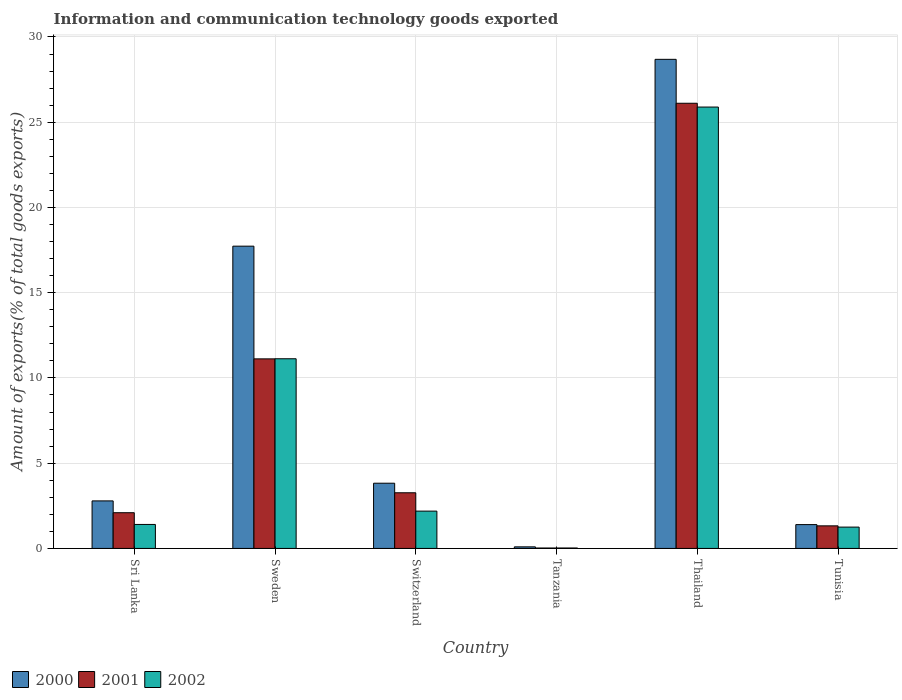Are the number of bars per tick equal to the number of legend labels?
Provide a succinct answer. Yes. How many bars are there on the 3rd tick from the left?
Make the answer very short. 3. What is the label of the 2nd group of bars from the left?
Your answer should be very brief. Sweden. In how many cases, is the number of bars for a given country not equal to the number of legend labels?
Provide a short and direct response. 0. What is the amount of goods exported in 2002 in Tunisia?
Make the answer very short. 1.25. Across all countries, what is the maximum amount of goods exported in 2001?
Offer a very short reply. 26.11. Across all countries, what is the minimum amount of goods exported in 2001?
Give a very brief answer. 0.03. In which country was the amount of goods exported in 2002 maximum?
Provide a short and direct response. Thailand. In which country was the amount of goods exported in 2000 minimum?
Provide a short and direct response. Tanzania. What is the total amount of goods exported in 2001 in the graph?
Provide a short and direct response. 43.94. What is the difference between the amount of goods exported in 2002 in Switzerland and that in Tunisia?
Ensure brevity in your answer.  0.94. What is the difference between the amount of goods exported in 2002 in Sri Lanka and the amount of goods exported in 2001 in Tunisia?
Ensure brevity in your answer.  0.08. What is the average amount of goods exported in 2000 per country?
Make the answer very short. 9.09. What is the difference between the amount of goods exported of/in 2000 and amount of goods exported of/in 2002 in Thailand?
Your answer should be very brief. 2.8. What is the ratio of the amount of goods exported in 2002 in Sweden to that in Tanzania?
Give a very brief answer. 436.69. Is the amount of goods exported in 2001 in Switzerland less than that in Thailand?
Your answer should be very brief. Yes. What is the difference between the highest and the second highest amount of goods exported in 2001?
Provide a succinct answer. -22.85. What is the difference between the highest and the lowest amount of goods exported in 2000?
Keep it short and to the point. 28.6. Is the sum of the amount of goods exported in 2000 in Sri Lanka and Tunisia greater than the maximum amount of goods exported in 2001 across all countries?
Ensure brevity in your answer.  No. What does the 2nd bar from the right in Sri Lanka represents?
Your answer should be compact. 2001. Is it the case that in every country, the sum of the amount of goods exported in 2002 and amount of goods exported in 2000 is greater than the amount of goods exported in 2001?
Your answer should be compact. Yes. Are all the bars in the graph horizontal?
Your answer should be very brief. No. How many countries are there in the graph?
Your answer should be very brief. 6. What is the difference between two consecutive major ticks on the Y-axis?
Give a very brief answer. 5. Are the values on the major ticks of Y-axis written in scientific E-notation?
Your answer should be very brief. No. How many legend labels are there?
Give a very brief answer. 3. What is the title of the graph?
Offer a very short reply. Information and communication technology goods exported. What is the label or title of the Y-axis?
Offer a very short reply. Amount of exports(% of total goods exports). What is the Amount of exports(% of total goods exports) in 2000 in Sri Lanka?
Your response must be concise. 2.79. What is the Amount of exports(% of total goods exports) of 2001 in Sri Lanka?
Make the answer very short. 2.1. What is the Amount of exports(% of total goods exports) in 2002 in Sri Lanka?
Offer a terse response. 1.41. What is the Amount of exports(% of total goods exports) of 2000 in Sweden?
Give a very brief answer. 17.73. What is the Amount of exports(% of total goods exports) of 2001 in Sweden?
Provide a short and direct response. 11.12. What is the Amount of exports(% of total goods exports) in 2002 in Sweden?
Provide a succinct answer. 11.13. What is the Amount of exports(% of total goods exports) in 2000 in Switzerland?
Give a very brief answer. 3.83. What is the Amount of exports(% of total goods exports) of 2001 in Switzerland?
Provide a short and direct response. 3.26. What is the Amount of exports(% of total goods exports) of 2002 in Switzerland?
Ensure brevity in your answer.  2.19. What is the Amount of exports(% of total goods exports) of 2000 in Tanzania?
Keep it short and to the point. 0.09. What is the Amount of exports(% of total goods exports) in 2001 in Tanzania?
Your answer should be very brief. 0.03. What is the Amount of exports(% of total goods exports) in 2002 in Tanzania?
Ensure brevity in your answer.  0.03. What is the Amount of exports(% of total goods exports) of 2000 in Thailand?
Give a very brief answer. 28.69. What is the Amount of exports(% of total goods exports) of 2001 in Thailand?
Provide a short and direct response. 26.11. What is the Amount of exports(% of total goods exports) in 2002 in Thailand?
Make the answer very short. 25.89. What is the Amount of exports(% of total goods exports) in 2000 in Tunisia?
Ensure brevity in your answer.  1.4. What is the Amount of exports(% of total goods exports) in 2001 in Tunisia?
Offer a terse response. 1.32. What is the Amount of exports(% of total goods exports) in 2002 in Tunisia?
Make the answer very short. 1.25. Across all countries, what is the maximum Amount of exports(% of total goods exports) of 2000?
Your response must be concise. 28.69. Across all countries, what is the maximum Amount of exports(% of total goods exports) of 2001?
Make the answer very short. 26.11. Across all countries, what is the maximum Amount of exports(% of total goods exports) of 2002?
Provide a succinct answer. 25.89. Across all countries, what is the minimum Amount of exports(% of total goods exports) in 2000?
Your answer should be compact. 0.09. Across all countries, what is the minimum Amount of exports(% of total goods exports) of 2001?
Your answer should be compact. 0.03. Across all countries, what is the minimum Amount of exports(% of total goods exports) in 2002?
Offer a very short reply. 0.03. What is the total Amount of exports(% of total goods exports) in 2000 in the graph?
Offer a very short reply. 54.52. What is the total Amount of exports(% of total goods exports) of 2001 in the graph?
Ensure brevity in your answer.  43.94. What is the total Amount of exports(% of total goods exports) in 2002 in the graph?
Offer a very short reply. 41.89. What is the difference between the Amount of exports(% of total goods exports) of 2000 in Sri Lanka and that in Sweden?
Keep it short and to the point. -14.94. What is the difference between the Amount of exports(% of total goods exports) of 2001 in Sri Lanka and that in Sweden?
Keep it short and to the point. -9.02. What is the difference between the Amount of exports(% of total goods exports) of 2002 in Sri Lanka and that in Sweden?
Provide a succinct answer. -9.72. What is the difference between the Amount of exports(% of total goods exports) in 2000 in Sri Lanka and that in Switzerland?
Make the answer very short. -1.04. What is the difference between the Amount of exports(% of total goods exports) of 2001 in Sri Lanka and that in Switzerland?
Ensure brevity in your answer.  -1.17. What is the difference between the Amount of exports(% of total goods exports) of 2002 in Sri Lanka and that in Switzerland?
Ensure brevity in your answer.  -0.78. What is the difference between the Amount of exports(% of total goods exports) in 2000 in Sri Lanka and that in Tanzania?
Offer a very short reply. 2.7. What is the difference between the Amount of exports(% of total goods exports) in 2001 in Sri Lanka and that in Tanzania?
Offer a very short reply. 2.07. What is the difference between the Amount of exports(% of total goods exports) of 2002 in Sri Lanka and that in Tanzania?
Keep it short and to the point. 1.38. What is the difference between the Amount of exports(% of total goods exports) in 2000 in Sri Lanka and that in Thailand?
Keep it short and to the point. -25.9. What is the difference between the Amount of exports(% of total goods exports) in 2001 in Sri Lanka and that in Thailand?
Provide a short and direct response. -24.02. What is the difference between the Amount of exports(% of total goods exports) of 2002 in Sri Lanka and that in Thailand?
Provide a succinct answer. -24.48. What is the difference between the Amount of exports(% of total goods exports) of 2000 in Sri Lanka and that in Tunisia?
Make the answer very short. 1.39. What is the difference between the Amount of exports(% of total goods exports) in 2001 in Sri Lanka and that in Tunisia?
Your answer should be compact. 0.77. What is the difference between the Amount of exports(% of total goods exports) in 2002 in Sri Lanka and that in Tunisia?
Your answer should be very brief. 0.16. What is the difference between the Amount of exports(% of total goods exports) in 2000 in Sweden and that in Switzerland?
Provide a succinct answer. 13.9. What is the difference between the Amount of exports(% of total goods exports) in 2001 in Sweden and that in Switzerland?
Your answer should be compact. 7.85. What is the difference between the Amount of exports(% of total goods exports) in 2002 in Sweden and that in Switzerland?
Ensure brevity in your answer.  8.94. What is the difference between the Amount of exports(% of total goods exports) of 2000 in Sweden and that in Tanzania?
Your response must be concise. 17.64. What is the difference between the Amount of exports(% of total goods exports) in 2001 in Sweden and that in Tanzania?
Provide a short and direct response. 11.09. What is the difference between the Amount of exports(% of total goods exports) of 2002 in Sweden and that in Tanzania?
Give a very brief answer. 11.1. What is the difference between the Amount of exports(% of total goods exports) of 2000 in Sweden and that in Thailand?
Ensure brevity in your answer.  -10.96. What is the difference between the Amount of exports(% of total goods exports) of 2001 in Sweden and that in Thailand?
Provide a short and direct response. -14.99. What is the difference between the Amount of exports(% of total goods exports) in 2002 in Sweden and that in Thailand?
Your response must be concise. -14.76. What is the difference between the Amount of exports(% of total goods exports) in 2000 in Sweden and that in Tunisia?
Offer a very short reply. 16.33. What is the difference between the Amount of exports(% of total goods exports) of 2001 in Sweden and that in Tunisia?
Your answer should be very brief. 9.79. What is the difference between the Amount of exports(% of total goods exports) in 2002 in Sweden and that in Tunisia?
Give a very brief answer. 9.87. What is the difference between the Amount of exports(% of total goods exports) in 2000 in Switzerland and that in Tanzania?
Give a very brief answer. 3.73. What is the difference between the Amount of exports(% of total goods exports) in 2001 in Switzerland and that in Tanzania?
Give a very brief answer. 3.24. What is the difference between the Amount of exports(% of total goods exports) of 2002 in Switzerland and that in Tanzania?
Make the answer very short. 2.16. What is the difference between the Amount of exports(% of total goods exports) in 2000 in Switzerland and that in Thailand?
Your response must be concise. -24.86. What is the difference between the Amount of exports(% of total goods exports) of 2001 in Switzerland and that in Thailand?
Keep it short and to the point. -22.85. What is the difference between the Amount of exports(% of total goods exports) of 2002 in Switzerland and that in Thailand?
Offer a terse response. -23.7. What is the difference between the Amount of exports(% of total goods exports) of 2000 in Switzerland and that in Tunisia?
Give a very brief answer. 2.43. What is the difference between the Amount of exports(% of total goods exports) of 2001 in Switzerland and that in Tunisia?
Ensure brevity in your answer.  1.94. What is the difference between the Amount of exports(% of total goods exports) of 2002 in Switzerland and that in Tunisia?
Give a very brief answer. 0.94. What is the difference between the Amount of exports(% of total goods exports) in 2000 in Tanzania and that in Thailand?
Offer a terse response. -28.6. What is the difference between the Amount of exports(% of total goods exports) of 2001 in Tanzania and that in Thailand?
Make the answer very short. -26.09. What is the difference between the Amount of exports(% of total goods exports) in 2002 in Tanzania and that in Thailand?
Your answer should be compact. -25.86. What is the difference between the Amount of exports(% of total goods exports) in 2000 in Tanzania and that in Tunisia?
Provide a short and direct response. -1.3. What is the difference between the Amount of exports(% of total goods exports) of 2001 in Tanzania and that in Tunisia?
Your answer should be compact. -1.3. What is the difference between the Amount of exports(% of total goods exports) of 2002 in Tanzania and that in Tunisia?
Your answer should be very brief. -1.23. What is the difference between the Amount of exports(% of total goods exports) in 2000 in Thailand and that in Tunisia?
Make the answer very short. 27.29. What is the difference between the Amount of exports(% of total goods exports) in 2001 in Thailand and that in Tunisia?
Your answer should be compact. 24.79. What is the difference between the Amount of exports(% of total goods exports) in 2002 in Thailand and that in Tunisia?
Offer a terse response. 24.64. What is the difference between the Amount of exports(% of total goods exports) of 2000 in Sri Lanka and the Amount of exports(% of total goods exports) of 2001 in Sweden?
Offer a terse response. -8.33. What is the difference between the Amount of exports(% of total goods exports) of 2000 in Sri Lanka and the Amount of exports(% of total goods exports) of 2002 in Sweden?
Your response must be concise. -8.34. What is the difference between the Amount of exports(% of total goods exports) in 2001 in Sri Lanka and the Amount of exports(% of total goods exports) in 2002 in Sweden?
Make the answer very short. -9.03. What is the difference between the Amount of exports(% of total goods exports) of 2000 in Sri Lanka and the Amount of exports(% of total goods exports) of 2001 in Switzerland?
Make the answer very short. -0.48. What is the difference between the Amount of exports(% of total goods exports) of 2000 in Sri Lanka and the Amount of exports(% of total goods exports) of 2002 in Switzerland?
Provide a succinct answer. 0.6. What is the difference between the Amount of exports(% of total goods exports) of 2001 in Sri Lanka and the Amount of exports(% of total goods exports) of 2002 in Switzerland?
Offer a terse response. -0.09. What is the difference between the Amount of exports(% of total goods exports) of 2000 in Sri Lanka and the Amount of exports(% of total goods exports) of 2001 in Tanzania?
Your answer should be compact. 2.76. What is the difference between the Amount of exports(% of total goods exports) in 2000 in Sri Lanka and the Amount of exports(% of total goods exports) in 2002 in Tanzania?
Your response must be concise. 2.76. What is the difference between the Amount of exports(% of total goods exports) in 2001 in Sri Lanka and the Amount of exports(% of total goods exports) in 2002 in Tanzania?
Your answer should be very brief. 2.07. What is the difference between the Amount of exports(% of total goods exports) in 2000 in Sri Lanka and the Amount of exports(% of total goods exports) in 2001 in Thailand?
Make the answer very short. -23.32. What is the difference between the Amount of exports(% of total goods exports) of 2000 in Sri Lanka and the Amount of exports(% of total goods exports) of 2002 in Thailand?
Ensure brevity in your answer.  -23.1. What is the difference between the Amount of exports(% of total goods exports) in 2001 in Sri Lanka and the Amount of exports(% of total goods exports) in 2002 in Thailand?
Make the answer very short. -23.79. What is the difference between the Amount of exports(% of total goods exports) of 2000 in Sri Lanka and the Amount of exports(% of total goods exports) of 2001 in Tunisia?
Ensure brevity in your answer.  1.46. What is the difference between the Amount of exports(% of total goods exports) in 2000 in Sri Lanka and the Amount of exports(% of total goods exports) in 2002 in Tunisia?
Keep it short and to the point. 1.54. What is the difference between the Amount of exports(% of total goods exports) in 2001 in Sri Lanka and the Amount of exports(% of total goods exports) in 2002 in Tunisia?
Your response must be concise. 0.84. What is the difference between the Amount of exports(% of total goods exports) of 2000 in Sweden and the Amount of exports(% of total goods exports) of 2001 in Switzerland?
Offer a terse response. 14.47. What is the difference between the Amount of exports(% of total goods exports) of 2000 in Sweden and the Amount of exports(% of total goods exports) of 2002 in Switzerland?
Keep it short and to the point. 15.54. What is the difference between the Amount of exports(% of total goods exports) in 2001 in Sweden and the Amount of exports(% of total goods exports) in 2002 in Switzerland?
Provide a succinct answer. 8.93. What is the difference between the Amount of exports(% of total goods exports) of 2000 in Sweden and the Amount of exports(% of total goods exports) of 2001 in Tanzania?
Ensure brevity in your answer.  17.7. What is the difference between the Amount of exports(% of total goods exports) in 2000 in Sweden and the Amount of exports(% of total goods exports) in 2002 in Tanzania?
Provide a short and direct response. 17.7. What is the difference between the Amount of exports(% of total goods exports) in 2001 in Sweden and the Amount of exports(% of total goods exports) in 2002 in Tanzania?
Your answer should be very brief. 11.09. What is the difference between the Amount of exports(% of total goods exports) in 2000 in Sweden and the Amount of exports(% of total goods exports) in 2001 in Thailand?
Make the answer very short. -8.38. What is the difference between the Amount of exports(% of total goods exports) in 2000 in Sweden and the Amount of exports(% of total goods exports) in 2002 in Thailand?
Your response must be concise. -8.16. What is the difference between the Amount of exports(% of total goods exports) of 2001 in Sweden and the Amount of exports(% of total goods exports) of 2002 in Thailand?
Your answer should be compact. -14.77. What is the difference between the Amount of exports(% of total goods exports) in 2000 in Sweden and the Amount of exports(% of total goods exports) in 2001 in Tunisia?
Ensure brevity in your answer.  16.41. What is the difference between the Amount of exports(% of total goods exports) of 2000 in Sweden and the Amount of exports(% of total goods exports) of 2002 in Tunisia?
Offer a very short reply. 16.48. What is the difference between the Amount of exports(% of total goods exports) in 2001 in Sweden and the Amount of exports(% of total goods exports) in 2002 in Tunisia?
Provide a short and direct response. 9.87. What is the difference between the Amount of exports(% of total goods exports) of 2000 in Switzerland and the Amount of exports(% of total goods exports) of 2001 in Tanzania?
Provide a succinct answer. 3.8. What is the difference between the Amount of exports(% of total goods exports) of 2001 in Switzerland and the Amount of exports(% of total goods exports) of 2002 in Tanzania?
Your answer should be compact. 3.24. What is the difference between the Amount of exports(% of total goods exports) of 2000 in Switzerland and the Amount of exports(% of total goods exports) of 2001 in Thailand?
Give a very brief answer. -22.29. What is the difference between the Amount of exports(% of total goods exports) of 2000 in Switzerland and the Amount of exports(% of total goods exports) of 2002 in Thailand?
Give a very brief answer. -22.06. What is the difference between the Amount of exports(% of total goods exports) of 2001 in Switzerland and the Amount of exports(% of total goods exports) of 2002 in Thailand?
Keep it short and to the point. -22.62. What is the difference between the Amount of exports(% of total goods exports) in 2000 in Switzerland and the Amount of exports(% of total goods exports) in 2001 in Tunisia?
Provide a short and direct response. 2.5. What is the difference between the Amount of exports(% of total goods exports) in 2000 in Switzerland and the Amount of exports(% of total goods exports) in 2002 in Tunisia?
Your answer should be very brief. 2.57. What is the difference between the Amount of exports(% of total goods exports) of 2001 in Switzerland and the Amount of exports(% of total goods exports) of 2002 in Tunisia?
Keep it short and to the point. 2.01. What is the difference between the Amount of exports(% of total goods exports) in 2000 in Tanzania and the Amount of exports(% of total goods exports) in 2001 in Thailand?
Your answer should be very brief. -26.02. What is the difference between the Amount of exports(% of total goods exports) of 2000 in Tanzania and the Amount of exports(% of total goods exports) of 2002 in Thailand?
Keep it short and to the point. -25.8. What is the difference between the Amount of exports(% of total goods exports) of 2001 in Tanzania and the Amount of exports(% of total goods exports) of 2002 in Thailand?
Make the answer very short. -25.86. What is the difference between the Amount of exports(% of total goods exports) in 2000 in Tanzania and the Amount of exports(% of total goods exports) in 2001 in Tunisia?
Provide a short and direct response. -1.23. What is the difference between the Amount of exports(% of total goods exports) in 2000 in Tanzania and the Amount of exports(% of total goods exports) in 2002 in Tunisia?
Keep it short and to the point. -1.16. What is the difference between the Amount of exports(% of total goods exports) of 2001 in Tanzania and the Amount of exports(% of total goods exports) of 2002 in Tunisia?
Your answer should be compact. -1.23. What is the difference between the Amount of exports(% of total goods exports) in 2000 in Thailand and the Amount of exports(% of total goods exports) in 2001 in Tunisia?
Provide a succinct answer. 27.36. What is the difference between the Amount of exports(% of total goods exports) in 2000 in Thailand and the Amount of exports(% of total goods exports) in 2002 in Tunisia?
Offer a terse response. 27.44. What is the difference between the Amount of exports(% of total goods exports) in 2001 in Thailand and the Amount of exports(% of total goods exports) in 2002 in Tunisia?
Provide a short and direct response. 24.86. What is the average Amount of exports(% of total goods exports) of 2000 per country?
Provide a short and direct response. 9.09. What is the average Amount of exports(% of total goods exports) in 2001 per country?
Your response must be concise. 7.32. What is the average Amount of exports(% of total goods exports) in 2002 per country?
Ensure brevity in your answer.  6.98. What is the difference between the Amount of exports(% of total goods exports) in 2000 and Amount of exports(% of total goods exports) in 2001 in Sri Lanka?
Offer a very short reply. 0.69. What is the difference between the Amount of exports(% of total goods exports) of 2000 and Amount of exports(% of total goods exports) of 2002 in Sri Lanka?
Provide a short and direct response. 1.38. What is the difference between the Amount of exports(% of total goods exports) in 2001 and Amount of exports(% of total goods exports) in 2002 in Sri Lanka?
Give a very brief answer. 0.69. What is the difference between the Amount of exports(% of total goods exports) in 2000 and Amount of exports(% of total goods exports) in 2001 in Sweden?
Ensure brevity in your answer.  6.61. What is the difference between the Amount of exports(% of total goods exports) of 2000 and Amount of exports(% of total goods exports) of 2002 in Sweden?
Ensure brevity in your answer.  6.6. What is the difference between the Amount of exports(% of total goods exports) in 2001 and Amount of exports(% of total goods exports) in 2002 in Sweden?
Your answer should be very brief. -0.01. What is the difference between the Amount of exports(% of total goods exports) of 2000 and Amount of exports(% of total goods exports) of 2001 in Switzerland?
Give a very brief answer. 0.56. What is the difference between the Amount of exports(% of total goods exports) of 2000 and Amount of exports(% of total goods exports) of 2002 in Switzerland?
Your answer should be very brief. 1.64. What is the difference between the Amount of exports(% of total goods exports) of 2001 and Amount of exports(% of total goods exports) of 2002 in Switzerland?
Provide a short and direct response. 1.08. What is the difference between the Amount of exports(% of total goods exports) of 2000 and Amount of exports(% of total goods exports) of 2001 in Tanzania?
Provide a succinct answer. 0.07. What is the difference between the Amount of exports(% of total goods exports) in 2000 and Amount of exports(% of total goods exports) in 2002 in Tanzania?
Your response must be concise. 0.07. What is the difference between the Amount of exports(% of total goods exports) of 2001 and Amount of exports(% of total goods exports) of 2002 in Tanzania?
Your answer should be very brief. -0. What is the difference between the Amount of exports(% of total goods exports) of 2000 and Amount of exports(% of total goods exports) of 2001 in Thailand?
Offer a very short reply. 2.58. What is the difference between the Amount of exports(% of total goods exports) in 2000 and Amount of exports(% of total goods exports) in 2002 in Thailand?
Your answer should be compact. 2.8. What is the difference between the Amount of exports(% of total goods exports) in 2001 and Amount of exports(% of total goods exports) in 2002 in Thailand?
Offer a very short reply. 0.22. What is the difference between the Amount of exports(% of total goods exports) of 2000 and Amount of exports(% of total goods exports) of 2001 in Tunisia?
Provide a short and direct response. 0.07. What is the difference between the Amount of exports(% of total goods exports) of 2000 and Amount of exports(% of total goods exports) of 2002 in Tunisia?
Ensure brevity in your answer.  0.15. What is the difference between the Amount of exports(% of total goods exports) in 2001 and Amount of exports(% of total goods exports) in 2002 in Tunisia?
Ensure brevity in your answer.  0.07. What is the ratio of the Amount of exports(% of total goods exports) in 2000 in Sri Lanka to that in Sweden?
Offer a terse response. 0.16. What is the ratio of the Amount of exports(% of total goods exports) of 2001 in Sri Lanka to that in Sweden?
Keep it short and to the point. 0.19. What is the ratio of the Amount of exports(% of total goods exports) in 2002 in Sri Lanka to that in Sweden?
Keep it short and to the point. 0.13. What is the ratio of the Amount of exports(% of total goods exports) of 2000 in Sri Lanka to that in Switzerland?
Make the answer very short. 0.73. What is the ratio of the Amount of exports(% of total goods exports) in 2001 in Sri Lanka to that in Switzerland?
Provide a succinct answer. 0.64. What is the ratio of the Amount of exports(% of total goods exports) of 2002 in Sri Lanka to that in Switzerland?
Provide a short and direct response. 0.64. What is the ratio of the Amount of exports(% of total goods exports) in 2000 in Sri Lanka to that in Tanzania?
Your response must be concise. 29.99. What is the ratio of the Amount of exports(% of total goods exports) in 2001 in Sri Lanka to that in Tanzania?
Make the answer very short. 82.64. What is the ratio of the Amount of exports(% of total goods exports) of 2002 in Sri Lanka to that in Tanzania?
Offer a terse response. 55.24. What is the ratio of the Amount of exports(% of total goods exports) in 2000 in Sri Lanka to that in Thailand?
Your response must be concise. 0.1. What is the ratio of the Amount of exports(% of total goods exports) of 2001 in Sri Lanka to that in Thailand?
Offer a terse response. 0.08. What is the ratio of the Amount of exports(% of total goods exports) in 2002 in Sri Lanka to that in Thailand?
Provide a succinct answer. 0.05. What is the ratio of the Amount of exports(% of total goods exports) in 2000 in Sri Lanka to that in Tunisia?
Keep it short and to the point. 2. What is the ratio of the Amount of exports(% of total goods exports) in 2001 in Sri Lanka to that in Tunisia?
Give a very brief answer. 1.58. What is the ratio of the Amount of exports(% of total goods exports) in 2002 in Sri Lanka to that in Tunisia?
Your answer should be very brief. 1.12. What is the ratio of the Amount of exports(% of total goods exports) of 2000 in Sweden to that in Switzerland?
Your answer should be very brief. 4.63. What is the ratio of the Amount of exports(% of total goods exports) of 2001 in Sweden to that in Switzerland?
Your answer should be very brief. 3.41. What is the ratio of the Amount of exports(% of total goods exports) of 2002 in Sweden to that in Switzerland?
Make the answer very short. 5.08. What is the ratio of the Amount of exports(% of total goods exports) of 2000 in Sweden to that in Tanzania?
Make the answer very short. 190.69. What is the ratio of the Amount of exports(% of total goods exports) in 2001 in Sweden to that in Tanzania?
Provide a succinct answer. 438.59. What is the ratio of the Amount of exports(% of total goods exports) in 2002 in Sweden to that in Tanzania?
Offer a very short reply. 436.69. What is the ratio of the Amount of exports(% of total goods exports) in 2000 in Sweden to that in Thailand?
Provide a succinct answer. 0.62. What is the ratio of the Amount of exports(% of total goods exports) of 2001 in Sweden to that in Thailand?
Provide a succinct answer. 0.43. What is the ratio of the Amount of exports(% of total goods exports) of 2002 in Sweden to that in Thailand?
Your response must be concise. 0.43. What is the ratio of the Amount of exports(% of total goods exports) in 2000 in Sweden to that in Tunisia?
Ensure brevity in your answer.  12.69. What is the ratio of the Amount of exports(% of total goods exports) of 2001 in Sweden to that in Tunisia?
Make the answer very short. 8.39. What is the ratio of the Amount of exports(% of total goods exports) in 2002 in Sweden to that in Tunisia?
Keep it short and to the point. 8.89. What is the ratio of the Amount of exports(% of total goods exports) of 2000 in Switzerland to that in Tanzania?
Your answer should be compact. 41.14. What is the ratio of the Amount of exports(% of total goods exports) of 2001 in Switzerland to that in Tanzania?
Your answer should be compact. 128.77. What is the ratio of the Amount of exports(% of total goods exports) of 2002 in Switzerland to that in Tanzania?
Keep it short and to the point. 85.91. What is the ratio of the Amount of exports(% of total goods exports) in 2000 in Switzerland to that in Thailand?
Offer a very short reply. 0.13. What is the ratio of the Amount of exports(% of total goods exports) of 2002 in Switzerland to that in Thailand?
Give a very brief answer. 0.08. What is the ratio of the Amount of exports(% of total goods exports) of 2000 in Switzerland to that in Tunisia?
Keep it short and to the point. 2.74. What is the ratio of the Amount of exports(% of total goods exports) in 2001 in Switzerland to that in Tunisia?
Ensure brevity in your answer.  2.46. What is the ratio of the Amount of exports(% of total goods exports) in 2002 in Switzerland to that in Tunisia?
Offer a very short reply. 1.75. What is the ratio of the Amount of exports(% of total goods exports) in 2000 in Tanzania to that in Thailand?
Provide a short and direct response. 0. What is the ratio of the Amount of exports(% of total goods exports) in 2002 in Tanzania to that in Thailand?
Offer a terse response. 0. What is the ratio of the Amount of exports(% of total goods exports) in 2000 in Tanzania to that in Tunisia?
Your response must be concise. 0.07. What is the ratio of the Amount of exports(% of total goods exports) of 2001 in Tanzania to that in Tunisia?
Keep it short and to the point. 0.02. What is the ratio of the Amount of exports(% of total goods exports) in 2002 in Tanzania to that in Tunisia?
Provide a short and direct response. 0.02. What is the ratio of the Amount of exports(% of total goods exports) in 2000 in Thailand to that in Tunisia?
Offer a terse response. 20.53. What is the ratio of the Amount of exports(% of total goods exports) in 2001 in Thailand to that in Tunisia?
Ensure brevity in your answer.  19.71. What is the ratio of the Amount of exports(% of total goods exports) in 2002 in Thailand to that in Tunisia?
Offer a terse response. 20.7. What is the difference between the highest and the second highest Amount of exports(% of total goods exports) in 2000?
Ensure brevity in your answer.  10.96. What is the difference between the highest and the second highest Amount of exports(% of total goods exports) of 2001?
Offer a very short reply. 14.99. What is the difference between the highest and the second highest Amount of exports(% of total goods exports) of 2002?
Ensure brevity in your answer.  14.76. What is the difference between the highest and the lowest Amount of exports(% of total goods exports) of 2000?
Provide a succinct answer. 28.6. What is the difference between the highest and the lowest Amount of exports(% of total goods exports) of 2001?
Your response must be concise. 26.09. What is the difference between the highest and the lowest Amount of exports(% of total goods exports) of 2002?
Your answer should be compact. 25.86. 